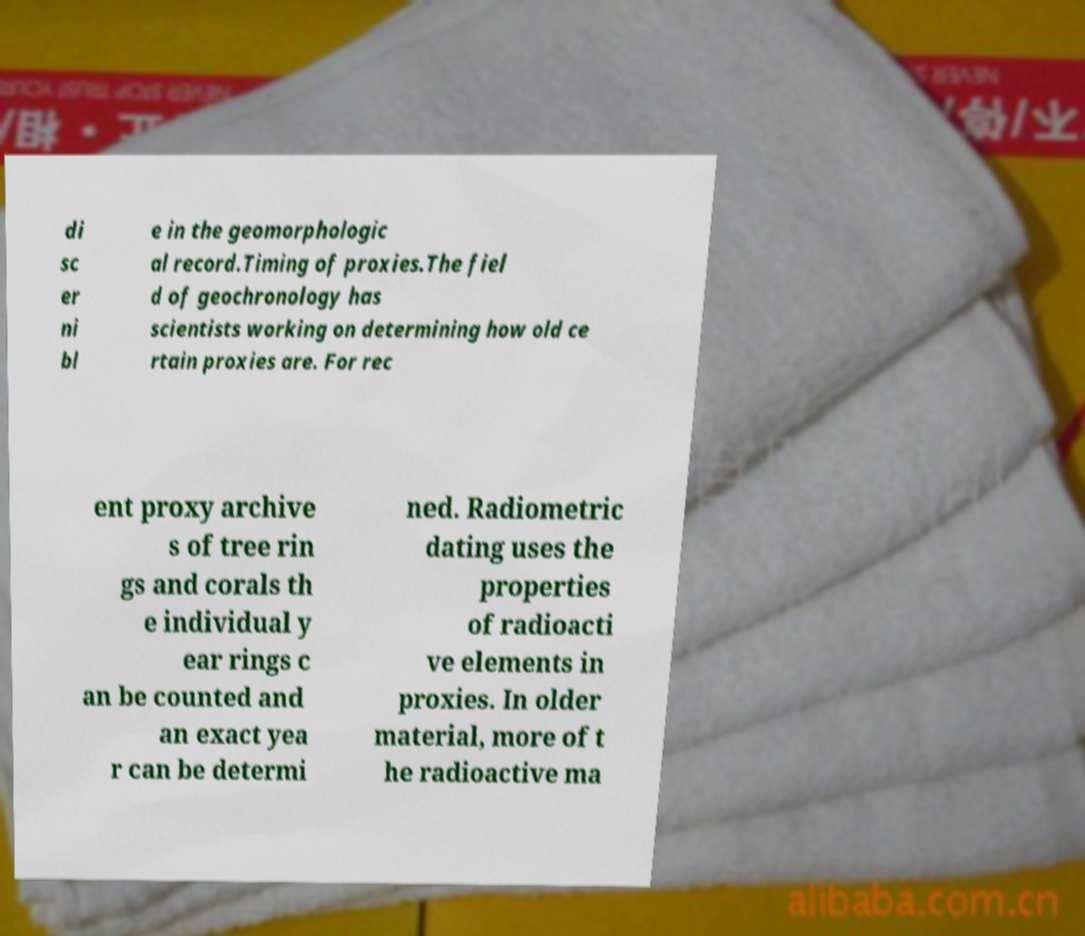I need the written content from this picture converted into text. Can you do that? di sc er ni bl e in the geomorphologic al record.Timing of proxies.The fiel d of geochronology has scientists working on determining how old ce rtain proxies are. For rec ent proxy archive s of tree rin gs and corals th e individual y ear rings c an be counted and an exact yea r can be determi ned. Radiometric dating uses the properties of radioacti ve elements in proxies. In older material, more of t he radioactive ma 